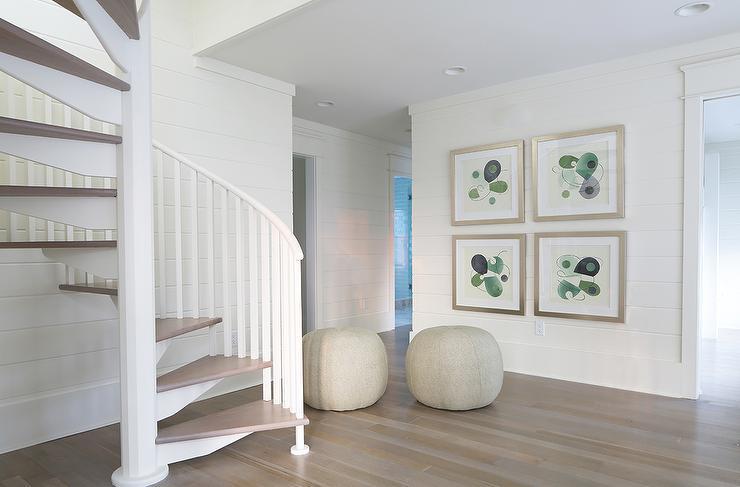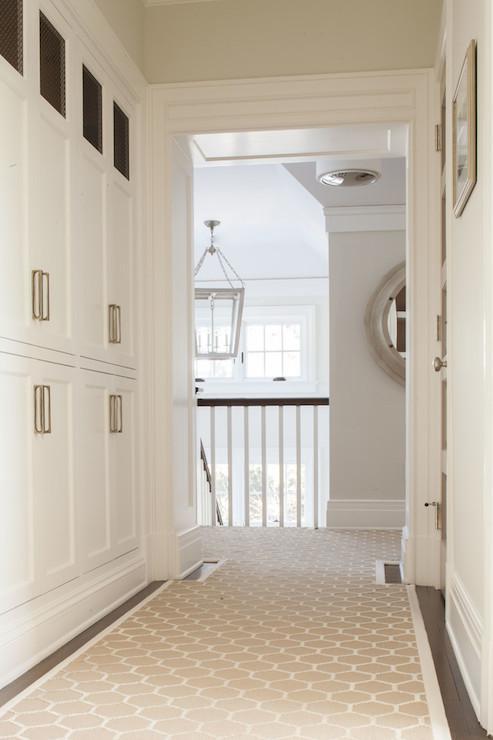The first image is the image on the left, the second image is the image on the right. Given the left and right images, does the statement "The left image has visible stair steps, the right image does not." hold true? Answer yes or no. Yes. The first image is the image on the left, the second image is the image on the right. Given the left and right images, does the statement "The right image is taken from downstairs." hold true? Answer yes or no. No. 